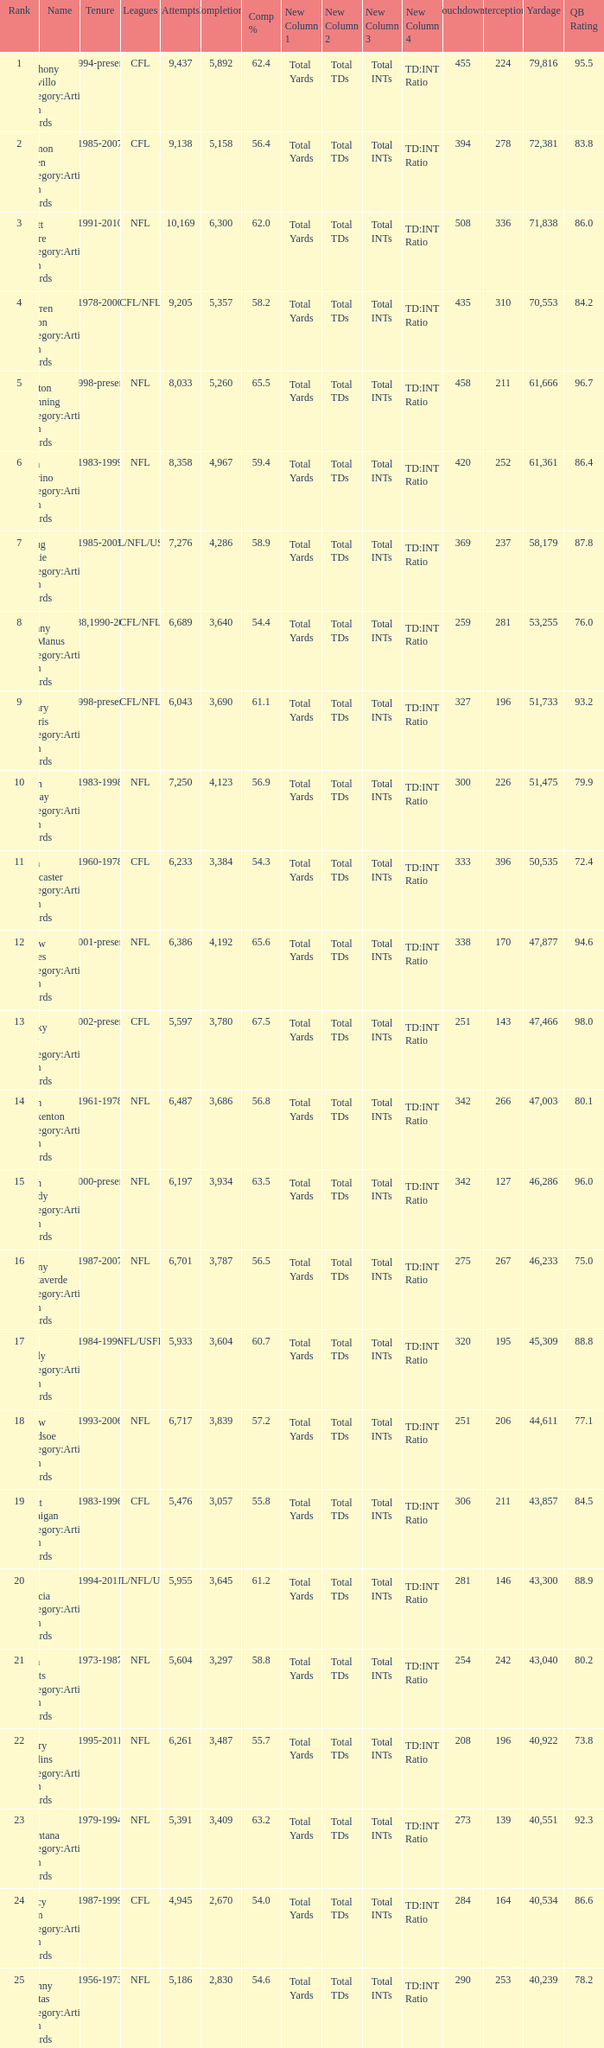What is the number of interceptions with less than 3,487 completions , more than 40,551 yardage, and the comp % is 55.8? 211.0. 